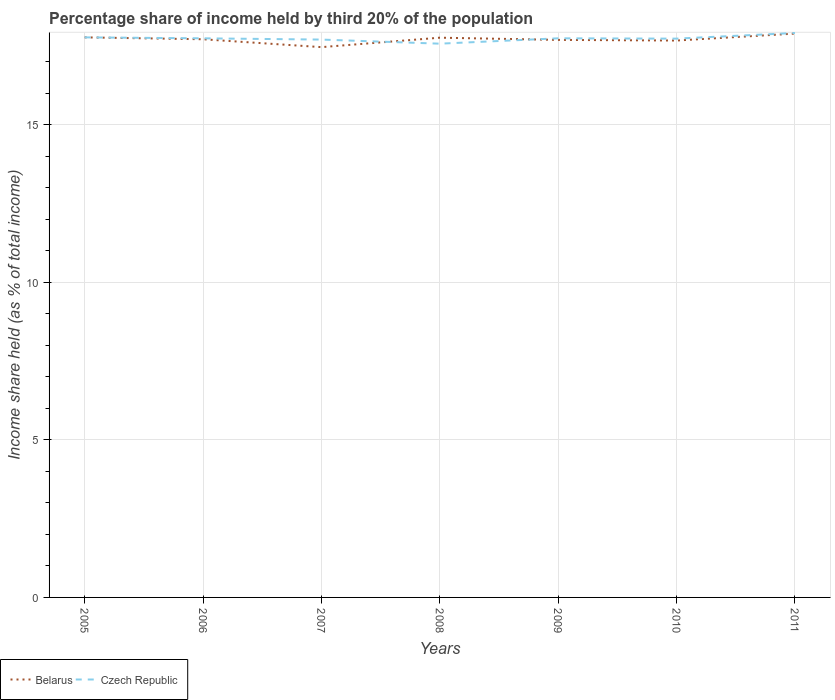How many different coloured lines are there?
Provide a short and direct response. 2. Does the line corresponding to Belarus intersect with the line corresponding to Czech Republic?
Make the answer very short. Yes. Is the number of lines equal to the number of legend labels?
Provide a succinct answer. Yes. Across all years, what is the maximum share of income held by third 20% of the population in Czech Republic?
Give a very brief answer. 17.57. What is the total share of income held by third 20% of the population in Czech Republic in the graph?
Your answer should be very brief. -0.21. What is the difference between the highest and the second highest share of income held by third 20% of the population in Belarus?
Offer a very short reply. 0.43. Is the share of income held by third 20% of the population in Belarus strictly greater than the share of income held by third 20% of the population in Czech Republic over the years?
Make the answer very short. No. What is the difference between two consecutive major ticks on the Y-axis?
Offer a very short reply. 5. How are the legend labels stacked?
Ensure brevity in your answer.  Horizontal. What is the title of the graph?
Your response must be concise. Percentage share of income held by third 20% of the population. Does "Pakistan" appear as one of the legend labels in the graph?
Provide a short and direct response. No. What is the label or title of the X-axis?
Provide a succinct answer. Years. What is the label or title of the Y-axis?
Keep it short and to the point. Income share held (as % of total income). What is the Income share held (as % of total income) of Belarus in 2005?
Offer a terse response. 17.77. What is the Income share held (as % of total income) in Czech Republic in 2005?
Keep it short and to the point. 17.77. What is the Income share held (as % of total income) of Belarus in 2006?
Make the answer very short. 17.71. What is the Income share held (as % of total income) in Czech Republic in 2006?
Ensure brevity in your answer.  17.74. What is the Income share held (as % of total income) of Belarus in 2007?
Give a very brief answer. 17.46. What is the Income share held (as % of total income) in Czech Republic in 2007?
Provide a short and direct response. 17.7. What is the Income share held (as % of total income) in Belarus in 2008?
Keep it short and to the point. 17.76. What is the Income share held (as % of total income) in Czech Republic in 2008?
Your answer should be very brief. 17.57. What is the Income share held (as % of total income) of Belarus in 2009?
Your response must be concise. 17.69. What is the Income share held (as % of total income) in Czech Republic in 2009?
Give a very brief answer. 17.74. What is the Income share held (as % of total income) of Belarus in 2010?
Your response must be concise. 17.67. What is the Income share held (as % of total income) in Czech Republic in 2010?
Offer a terse response. 17.73. What is the Income share held (as % of total income) of Belarus in 2011?
Your answer should be very brief. 17.89. What is the Income share held (as % of total income) in Czech Republic in 2011?
Make the answer very short. 17.91. Across all years, what is the maximum Income share held (as % of total income) of Belarus?
Provide a short and direct response. 17.89. Across all years, what is the maximum Income share held (as % of total income) in Czech Republic?
Offer a very short reply. 17.91. Across all years, what is the minimum Income share held (as % of total income) of Belarus?
Provide a succinct answer. 17.46. Across all years, what is the minimum Income share held (as % of total income) in Czech Republic?
Offer a terse response. 17.57. What is the total Income share held (as % of total income) in Belarus in the graph?
Ensure brevity in your answer.  123.95. What is the total Income share held (as % of total income) of Czech Republic in the graph?
Your response must be concise. 124.16. What is the difference between the Income share held (as % of total income) of Czech Republic in 2005 and that in 2006?
Your response must be concise. 0.03. What is the difference between the Income share held (as % of total income) of Belarus in 2005 and that in 2007?
Your response must be concise. 0.31. What is the difference between the Income share held (as % of total income) of Czech Republic in 2005 and that in 2007?
Offer a very short reply. 0.07. What is the difference between the Income share held (as % of total income) in Czech Republic in 2005 and that in 2008?
Provide a succinct answer. 0.2. What is the difference between the Income share held (as % of total income) in Belarus in 2005 and that in 2009?
Ensure brevity in your answer.  0.08. What is the difference between the Income share held (as % of total income) of Czech Republic in 2005 and that in 2009?
Your answer should be very brief. 0.03. What is the difference between the Income share held (as % of total income) in Czech Republic in 2005 and that in 2010?
Offer a terse response. 0.04. What is the difference between the Income share held (as % of total income) of Belarus in 2005 and that in 2011?
Keep it short and to the point. -0.12. What is the difference between the Income share held (as % of total income) of Czech Republic in 2005 and that in 2011?
Offer a very short reply. -0.14. What is the difference between the Income share held (as % of total income) in Czech Republic in 2006 and that in 2008?
Provide a succinct answer. 0.17. What is the difference between the Income share held (as % of total income) of Belarus in 2006 and that in 2009?
Offer a very short reply. 0.02. What is the difference between the Income share held (as % of total income) in Czech Republic in 2006 and that in 2010?
Offer a terse response. 0.01. What is the difference between the Income share held (as % of total income) of Belarus in 2006 and that in 2011?
Give a very brief answer. -0.18. What is the difference between the Income share held (as % of total income) in Czech Republic in 2006 and that in 2011?
Give a very brief answer. -0.17. What is the difference between the Income share held (as % of total income) of Czech Republic in 2007 and that in 2008?
Give a very brief answer. 0.13. What is the difference between the Income share held (as % of total income) in Belarus in 2007 and that in 2009?
Keep it short and to the point. -0.23. What is the difference between the Income share held (as % of total income) of Czech Republic in 2007 and that in 2009?
Your answer should be very brief. -0.04. What is the difference between the Income share held (as % of total income) of Belarus in 2007 and that in 2010?
Your response must be concise. -0.21. What is the difference between the Income share held (as % of total income) of Czech Republic in 2007 and that in 2010?
Make the answer very short. -0.03. What is the difference between the Income share held (as % of total income) in Belarus in 2007 and that in 2011?
Offer a very short reply. -0.43. What is the difference between the Income share held (as % of total income) of Czech Republic in 2007 and that in 2011?
Offer a terse response. -0.21. What is the difference between the Income share held (as % of total income) of Belarus in 2008 and that in 2009?
Give a very brief answer. 0.07. What is the difference between the Income share held (as % of total income) of Czech Republic in 2008 and that in 2009?
Offer a terse response. -0.17. What is the difference between the Income share held (as % of total income) of Belarus in 2008 and that in 2010?
Your response must be concise. 0.09. What is the difference between the Income share held (as % of total income) in Czech Republic in 2008 and that in 2010?
Provide a succinct answer. -0.16. What is the difference between the Income share held (as % of total income) in Belarus in 2008 and that in 2011?
Your response must be concise. -0.13. What is the difference between the Income share held (as % of total income) in Czech Republic in 2008 and that in 2011?
Make the answer very short. -0.34. What is the difference between the Income share held (as % of total income) of Belarus in 2009 and that in 2011?
Ensure brevity in your answer.  -0.2. What is the difference between the Income share held (as % of total income) of Czech Republic in 2009 and that in 2011?
Keep it short and to the point. -0.17. What is the difference between the Income share held (as % of total income) of Belarus in 2010 and that in 2011?
Offer a very short reply. -0.22. What is the difference between the Income share held (as % of total income) in Czech Republic in 2010 and that in 2011?
Ensure brevity in your answer.  -0.18. What is the difference between the Income share held (as % of total income) in Belarus in 2005 and the Income share held (as % of total income) in Czech Republic in 2006?
Make the answer very short. 0.03. What is the difference between the Income share held (as % of total income) of Belarus in 2005 and the Income share held (as % of total income) of Czech Republic in 2007?
Your answer should be compact. 0.07. What is the difference between the Income share held (as % of total income) of Belarus in 2005 and the Income share held (as % of total income) of Czech Republic in 2009?
Your answer should be very brief. 0.03. What is the difference between the Income share held (as % of total income) of Belarus in 2005 and the Income share held (as % of total income) of Czech Republic in 2010?
Make the answer very short. 0.04. What is the difference between the Income share held (as % of total income) of Belarus in 2005 and the Income share held (as % of total income) of Czech Republic in 2011?
Your response must be concise. -0.14. What is the difference between the Income share held (as % of total income) in Belarus in 2006 and the Income share held (as % of total income) in Czech Republic in 2007?
Your response must be concise. 0.01. What is the difference between the Income share held (as % of total income) in Belarus in 2006 and the Income share held (as % of total income) in Czech Republic in 2008?
Offer a very short reply. 0.14. What is the difference between the Income share held (as % of total income) of Belarus in 2006 and the Income share held (as % of total income) of Czech Republic in 2009?
Offer a very short reply. -0.03. What is the difference between the Income share held (as % of total income) of Belarus in 2006 and the Income share held (as % of total income) of Czech Republic in 2010?
Ensure brevity in your answer.  -0.02. What is the difference between the Income share held (as % of total income) in Belarus in 2006 and the Income share held (as % of total income) in Czech Republic in 2011?
Your answer should be very brief. -0.2. What is the difference between the Income share held (as % of total income) of Belarus in 2007 and the Income share held (as % of total income) of Czech Republic in 2008?
Your answer should be very brief. -0.11. What is the difference between the Income share held (as % of total income) in Belarus in 2007 and the Income share held (as % of total income) in Czech Republic in 2009?
Give a very brief answer. -0.28. What is the difference between the Income share held (as % of total income) in Belarus in 2007 and the Income share held (as % of total income) in Czech Republic in 2010?
Give a very brief answer. -0.27. What is the difference between the Income share held (as % of total income) of Belarus in 2007 and the Income share held (as % of total income) of Czech Republic in 2011?
Offer a very short reply. -0.45. What is the difference between the Income share held (as % of total income) in Belarus in 2008 and the Income share held (as % of total income) in Czech Republic in 2010?
Your answer should be very brief. 0.03. What is the difference between the Income share held (as % of total income) of Belarus in 2009 and the Income share held (as % of total income) of Czech Republic in 2010?
Your response must be concise. -0.04. What is the difference between the Income share held (as % of total income) of Belarus in 2009 and the Income share held (as % of total income) of Czech Republic in 2011?
Ensure brevity in your answer.  -0.22. What is the difference between the Income share held (as % of total income) in Belarus in 2010 and the Income share held (as % of total income) in Czech Republic in 2011?
Ensure brevity in your answer.  -0.24. What is the average Income share held (as % of total income) in Belarus per year?
Give a very brief answer. 17.71. What is the average Income share held (as % of total income) of Czech Republic per year?
Keep it short and to the point. 17.74. In the year 2005, what is the difference between the Income share held (as % of total income) of Belarus and Income share held (as % of total income) of Czech Republic?
Offer a terse response. 0. In the year 2006, what is the difference between the Income share held (as % of total income) of Belarus and Income share held (as % of total income) of Czech Republic?
Keep it short and to the point. -0.03. In the year 2007, what is the difference between the Income share held (as % of total income) in Belarus and Income share held (as % of total income) in Czech Republic?
Your answer should be very brief. -0.24. In the year 2008, what is the difference between the Income share held (as % of total income) of Belarus and Income share held (as % of total income) of Czech Republic?
Your answer should be compact. 0.19. In the year 2010, what is the difference between the Income share held (as % of total income) in Belarus and Income share held (as % of total income) in Czech Republic?
Keep it short and to the point. -0.06. In the year 2011, what is the difference between the Income share held (as % of total income) of Belarus and Income share held (as % of total income) of Czech Republic?
Your response must be concise. -0.02. What is the ratio of the Income share held (as % of total income) of Belarus in 2005 to that in 2006?
Offer a very short reply. 1. What is the ratio of the Income share held (as % of total income) in Belarus in 2005 to that in 2007?
Provide a succinct answer. 1.02. What is the ratio of the Income share held (as % of total income) of Belarus in 2005 to that in 2008?
Offer a very short reply. 1. What is the ratio of the Income share held (as % of total income) in Czech Republic in 2005 to that in 2008?
Keep it short and to the point. 1.01. What is the ratio of the Income share held (as % of total income) in Belarus in 2005 to that in 2010?
Offer a terse response. 1.01. What is the ratio of the Income share held (as % of total income) of Belarus in 2006 to that in 2007?
Ensure brevity in your answer.  1.01. What is the ratio of the Income share held (as % of total income) in Belarus in 2006 to that in 2008?
Make the answer very short. 1. What is the ratio of the Income share held (as % of total income) in Czech Republic in 2006 to that in 2008?
Give a very brief answer. 1.01. What is the ratio of the Income share held (as % of total income) of Belarus in 2006 to that in 2010?
Keep it short and to the point. 1. What is the ratio of the Income share held (as % of total income) in Czech Republic in 2006 to that in 2010?
Offer a very short reply. 1. What is the ratio of the Income share held (as % of total income) in Belarus in 2006 to that in 2011?
Provide a short and direct response. 0.99. What is the ratio of the Income share held (as % of total income) in Czech Republic in 2006 to that in 2011?
Provide a short and direct response. 0.99. What is the ratio of the Income share held (as % of total income) of Belarus in 2007 to that in 2008?
Give a very brief answer. 0.98. What is the ratio of the Income share held (as % of total income) of Czech Republic in 2007 to that in 2008?
Your response must be concise. 1.01. What is the ratio of the Income share held (as % of total income) in Belarus in 2007 to that in 2009?
Your answer should be very brief. 0.99. What is the ratio of the Income share held (as % of total income) of Czech Republic in 2007 to that in 2009?
Ensure brevity in your answer.  1. What is the ratio of the Income share held (as % of total income) in Belarus in 2007 to that in 2010?
Your answer should be compact. 0.99. What is the ratio of the Income share held (as % of total income) in Czech Republic in 2007 to that in 2010?
Give a very brief answer. 1. What is the ratio of the Income share held (as % of total income) in Belarus in 2007 to that in 2011?
Your response must be concise. 0.98. What is the ratio of the Income share held (as % of total income) in Czech Republic in 2007 to that in 2011?
Offer a terse response. 0.99. What is the ratio of the Income share held (as % of total income) of Czech Republic in 2008 to that in 2010?
Your answer should be very brief. 0.99. What is the ratio of the Income share held (as % of total income) of Belarus in 2008 to that in 2011?
Offer a terse response. 0.99. What is the ratio of the Income share held (as % of total income) in Belarus in 2009 to that in 2011?
Offer a terse response. 0.99. What is the ratio of the Income share held (as % of total income) in Czech Republic in 2009 to that in 2011?
Make the answer very short. 0.99. What is the difference between the highest and the second highest Income share held (as % of total income) of Belarus?
Provide a succinct answer. 0.12. What is the difference between the highest and the second highest Income share held (as % of total income) of Czech Republic?
Keep it short and to the point. 0.14. What is the difference between the highest and the lowest Income share held (as % of total income) in Belarus?
Ensure brevity in your answer.  0.43. What is the difference between the highest and the lowest Income share held (as % of total income) in Czech Republic?
Your answer should be compact. 0.34. 